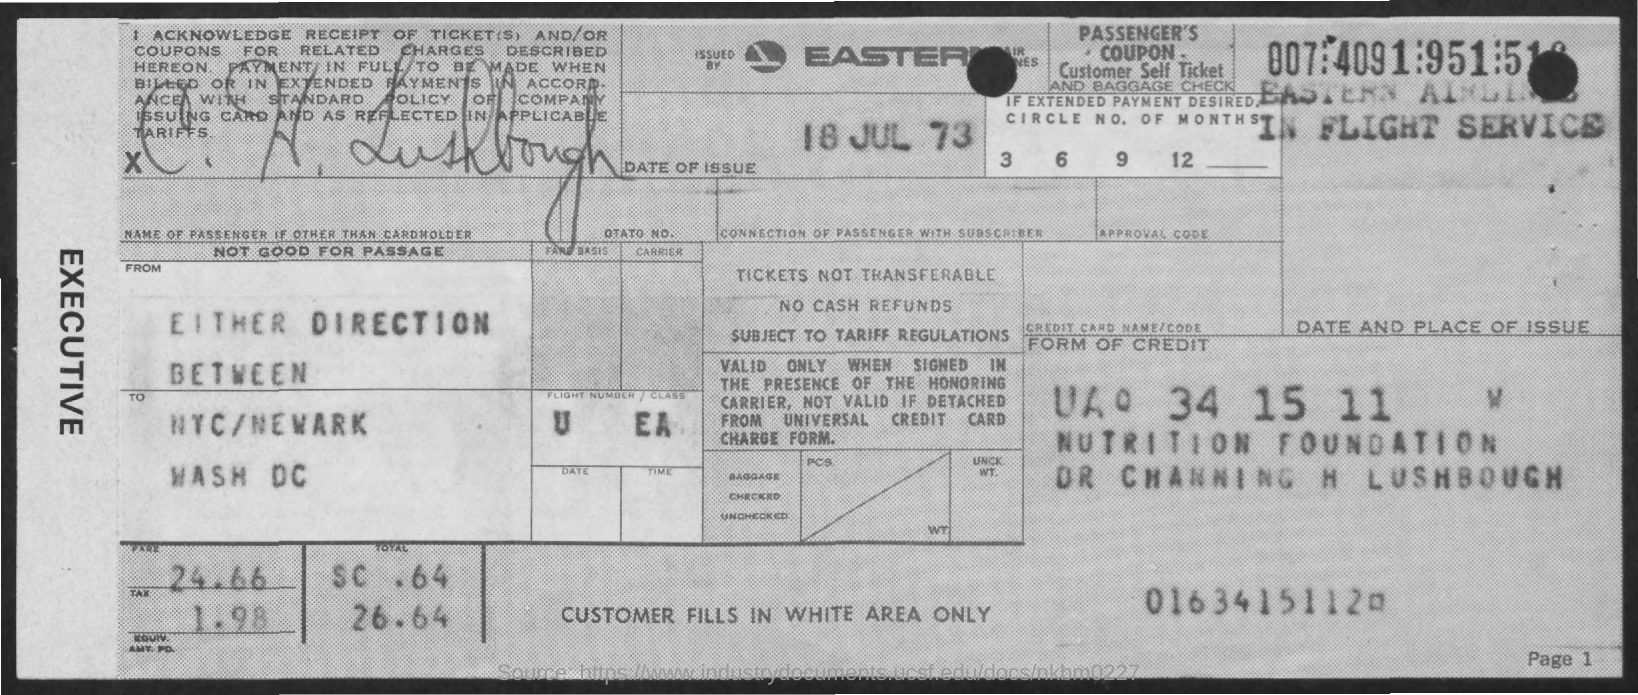Point out several critical features in this image. The fare is 24.66 cents. The date of issue is July 18, 1973. What is the tax? 1.98..." is a question asking for information about a tax amount. 